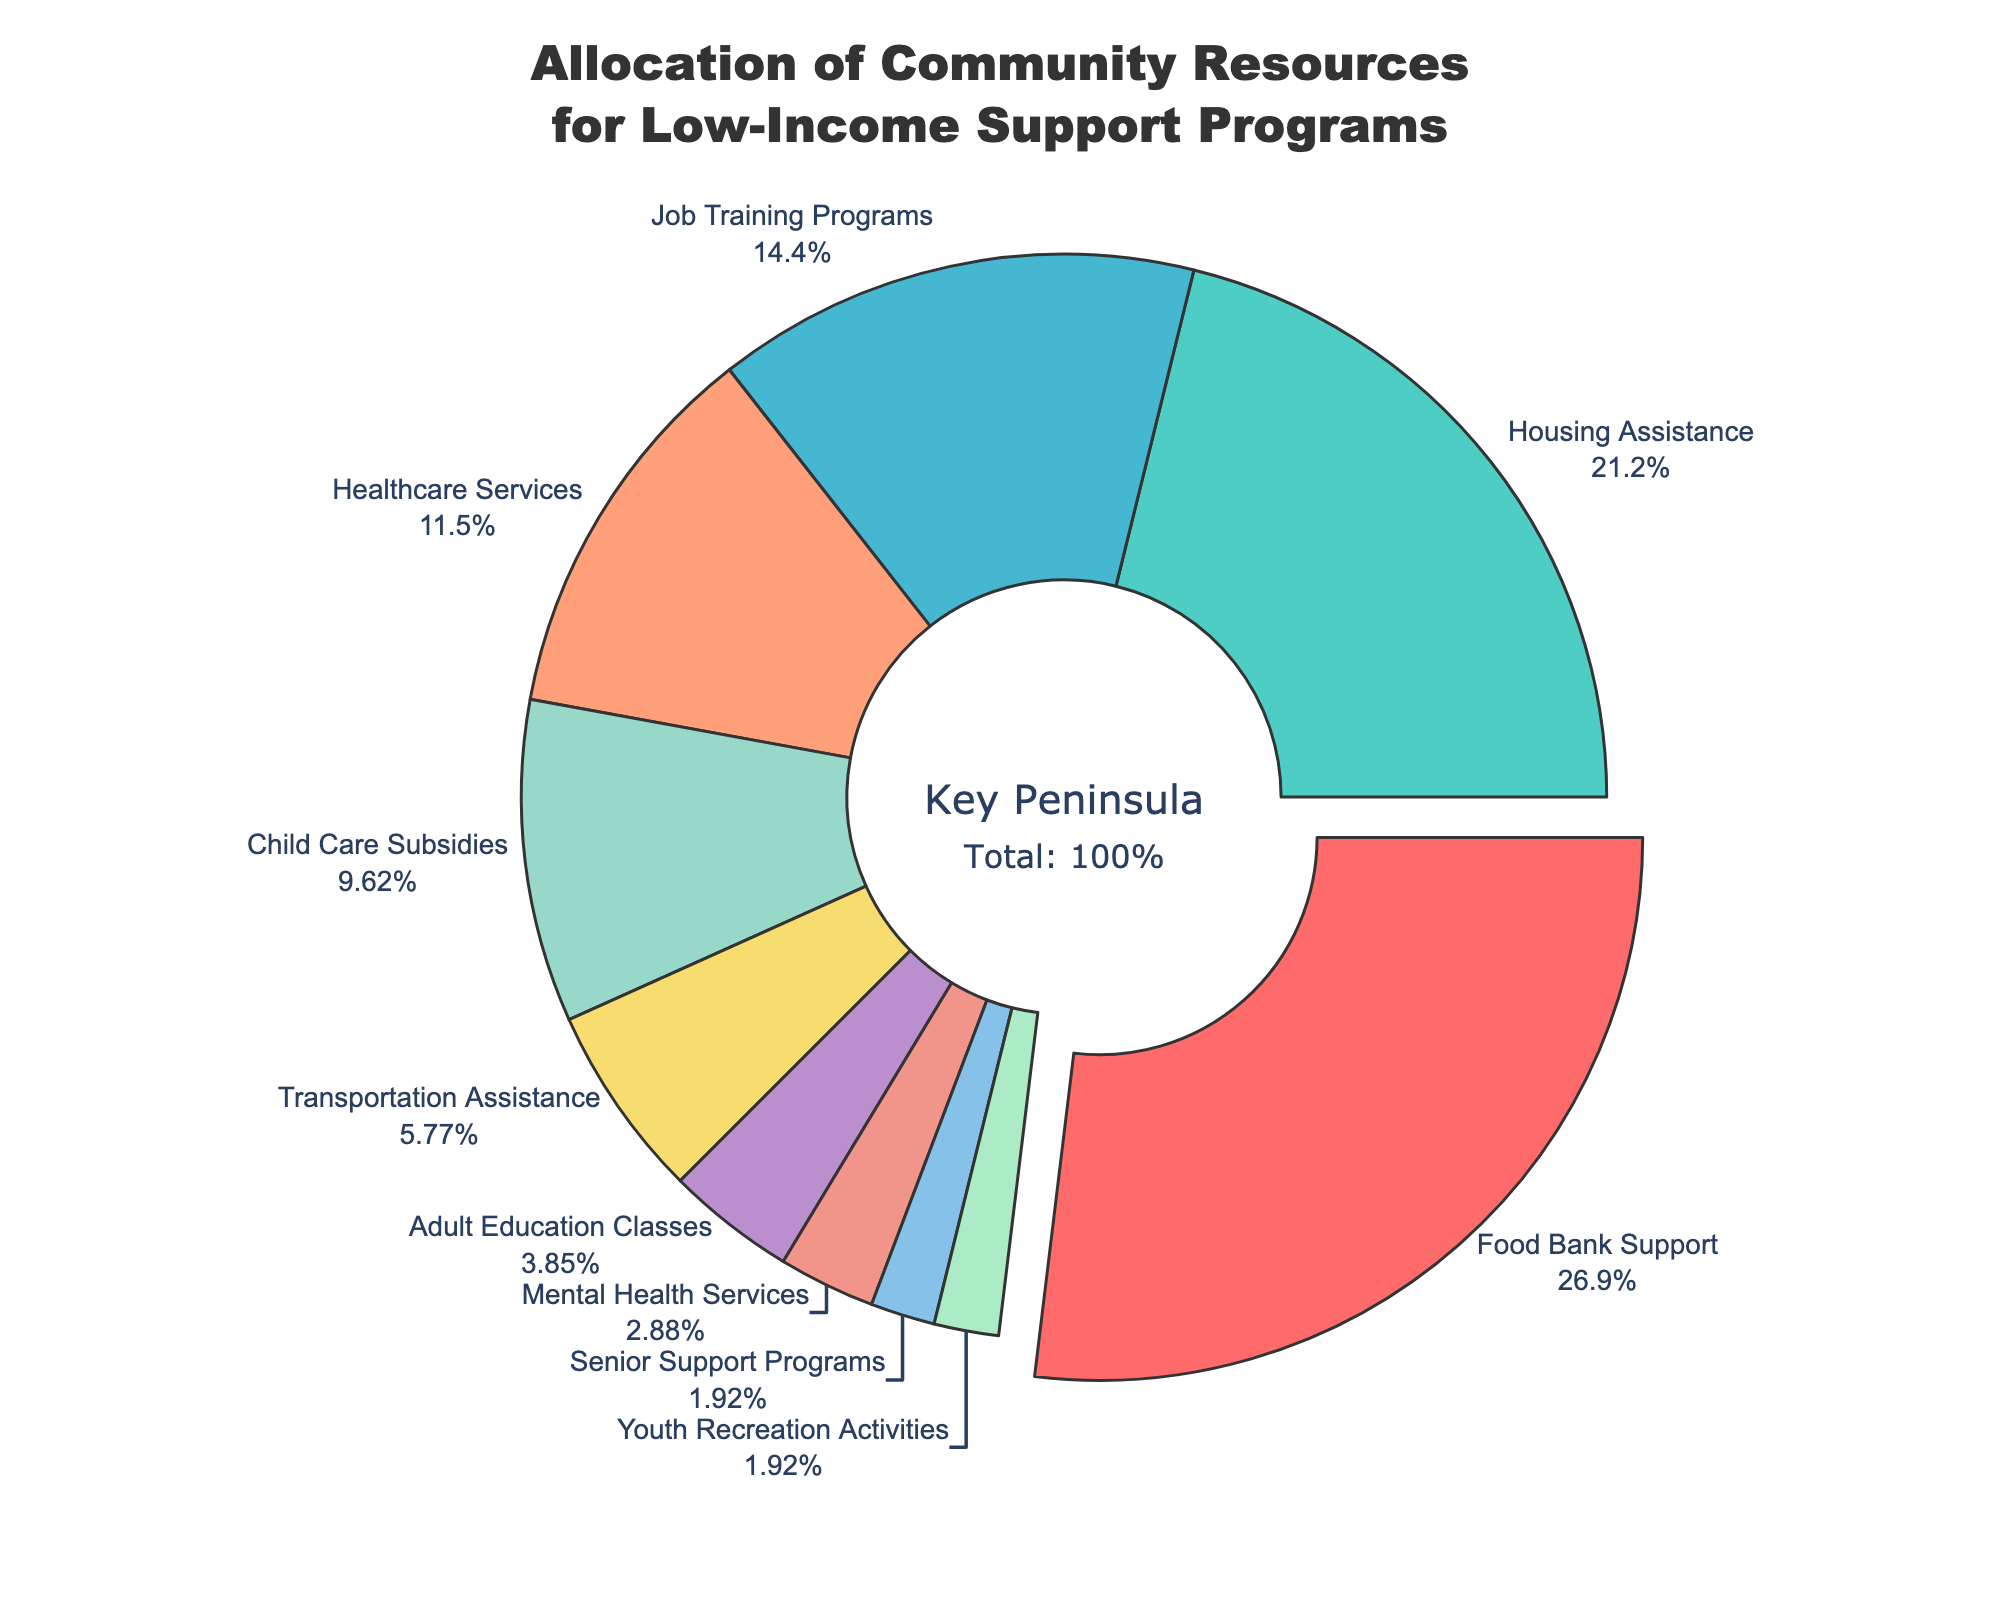What is the percentage allocated for Food Bank Support? The figure shows that Food Bank Support receives the highest allocation. According to the labels, it is allocated 28% of the resources.
Answer: 28% Which program receives more resources, Housing Assistance or Job Training Programs? By comparing the allocation percentages shown in the figure, Housing Assistance has 22%, while Job Training Programs has 15%. Clearly, Housing Assistance receives more resources.
Answer: Housing Assistance What is the combined allocation percentage for Adult Education Classes, Mental Health Services, Senior Support Programs, and Youth Recreation Activities? To find the combined allocation, sum the percentages for each program: 4% (Adult Education Classes) + 3% (Mental Health Services) + 2% (Senior Support Programs) + 2% (Youth Recreation Activities) = 11%.
Answer: 11% How much more is allocated to Child Care Subsidies compared to Transportation Assistance? Child Care Subsidies have an allocation of 10%, while Transportation Assistance has 6%. The difference is 10% - 6% = 4%.
Answer: 4% Which programs are allocated less than 5% of the resources? By listing the programs with allocations below 5%, we have: Adult Education Classes (4%), Mental Health Services (3%), Senior Support Programs (2%), and Youth Recreation Activities (2%).
Answer: Adult Education Classes, Mental Health Services, Senior Support Programs, Youth Recreation Activities What are the percentages for the top three highest allocated programs? The top three programs by resource allocation percentages are: Food Bank Support (28%), Housing Assistance (22%), and Job Training Programs (15%).
Answer: 28%, 22%, 15% Is the allocation for Healthcare Services greater than the combined allocation for both Senior Support Programs and Youth Recreation Activities? Healthcare Services has 12%. The combined allocation for Senior Support Programs and Youth Recreation Activities is 2% + 2% = 4%. Since 12% is greater than 4%, the answer is yes.
Answer: Yes What color is associated with Housing Assistance in the chart? Visually locating Housing Assistance in the pie chart, it is colored with a shade of cyan.
Answer: Cyan If the percentages allocated to Child Care Subsidies and Transportation Assistance are doubled, will their sum exceed that of Food Bank Support? Doubling Child Care Subsidies (10% * 2 = 20%) and Transportation Assistance (6% * 2 = 12%) gives a total of 20% + 12% = 32%. This exceeds Food Bank Support's 28%.
Answer: Yes Which program's slice is pulled out from the pie chart? The figure has one slice pulled out which corresponds to the largest allocation, Food Bank Support, indicating its importance.
Answer: Food Bank Support 